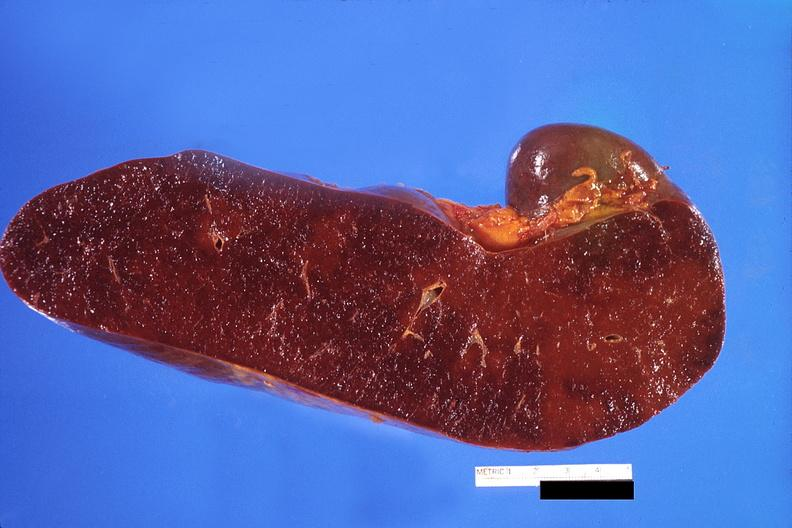where is this part in?
Answer the question using a single word or phrase. Spleen 